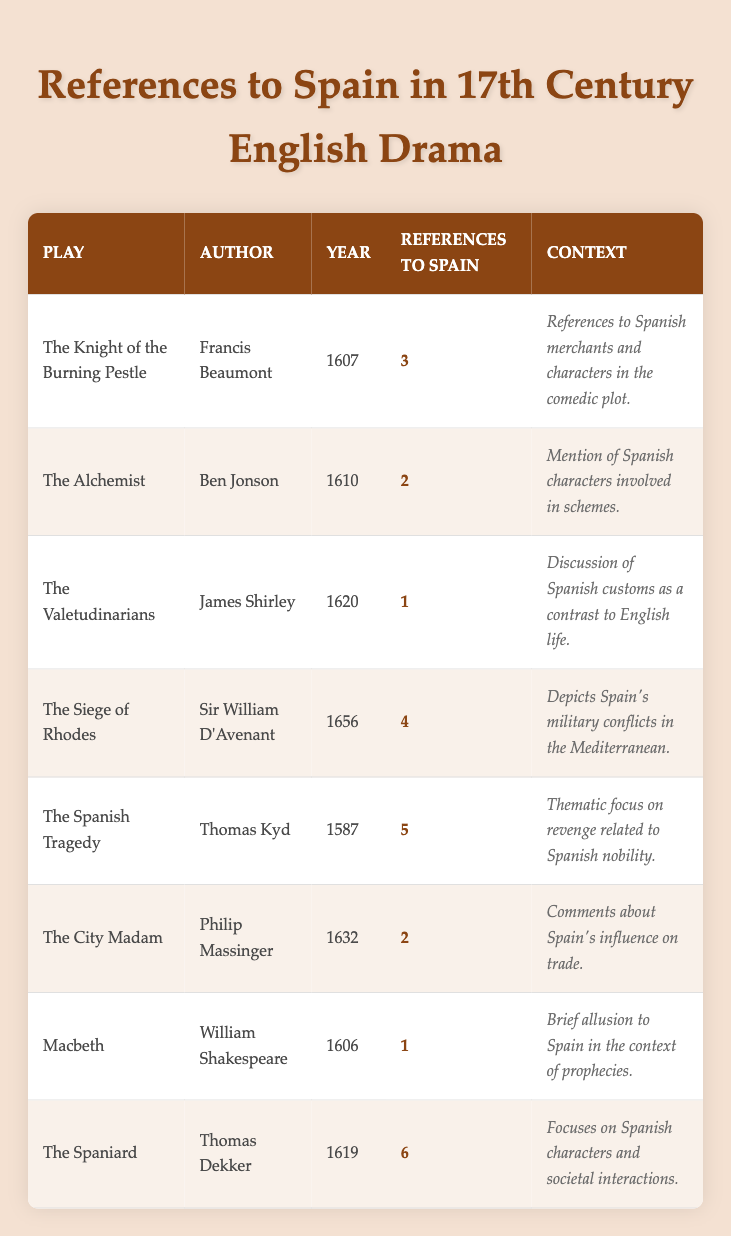What is the play with the highest number of references to Spain? By examining the "References to Spain" column, the highest value is 6, which corresponds to "The Spaniard" by Thomas Dekker.
Answer: The Spaniard Which author has the most plays listed in the table? We count the number of plays for each author in the table. Francis Beaumont, Ben Jonson, James Shirley, Philip Massinger, William Shakespeare, Thomas Kyd, Sir William D’Avenant, and Thomas Dekker each have one play, resulting in no author having more than one.
Answer: None What is the total number of references to Spain across all plays? Adding the references: 3 + 2 + 1 + 4 + 5 + 2 + 1 + 6 = 24. Therefore, the total number of references to Spain is 24.
Answer: 24 Was there any play before 1600 that references Spain? Looking at the table, only one play, "The Spanish Tragedy," which is listed as 1587, references Spain, making the answer yes.
Answer: Yes What is the average number of references to Spain per play? There are 8 plays listed, and the total number of references is 24. To calculate the average, divide 24 by 8, which results in 3.
Answer: 3 Which play mentions Spain in the context of comedy? The play "The Knight of the Burning Pestle" mentions Spain within a comedic plot context, as indicated in the "Context" column.
Answer: The Knight of the Burning Pestle What is the difference in the number of references to Spain between "The Siege of Rhodes" and "The Alchemist"? "The Siege of Rhodes" has 4 references, while "The Alchemist" has 2 references. The difference is 4 - 2 = 2.
Answer: 2 Which play provides a context relating Spanish customs to English life? The play "The Valetudinarians" discusses Spanish customs as a contrast to English life, as noted in its context description.
Answer: The Valetudinarians How many plays reference Spain twice? "The Alchemist" and "The City Madam" each reference Spain 2 times, making a total of 2 plays in this category.
Answer: 2 